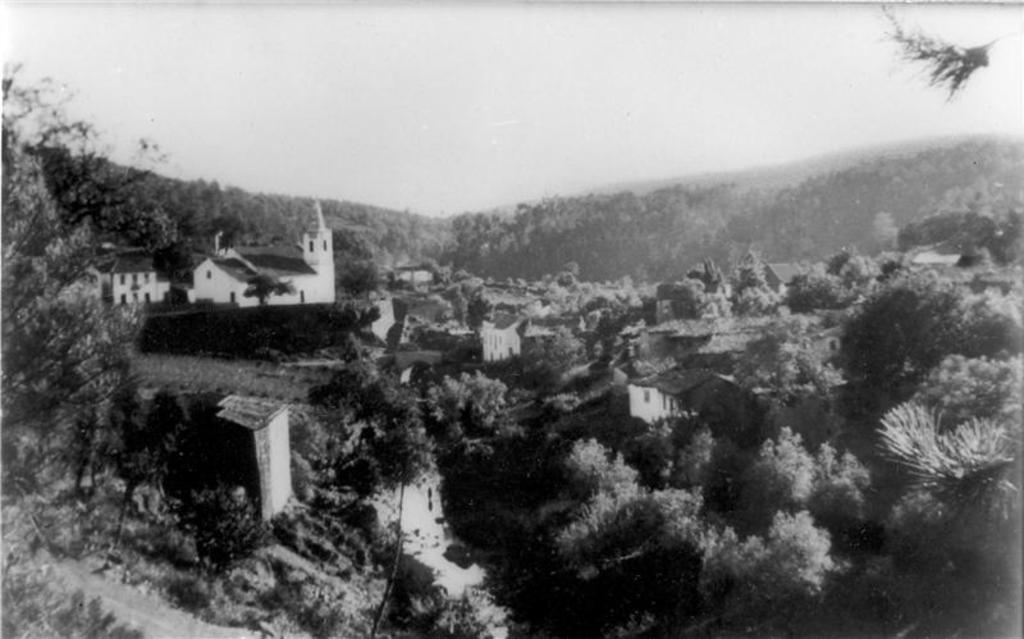What type of vegetation can be seen in the image? There are trees in the image. What type of structures are present in the image? There are buildings in the image. What is visible at the top of the image? The sky is visible at the top of the image. Where is the library located in the image? There is no library present in the image. What type of powder is being used in the image? There is no powder present in the image. 